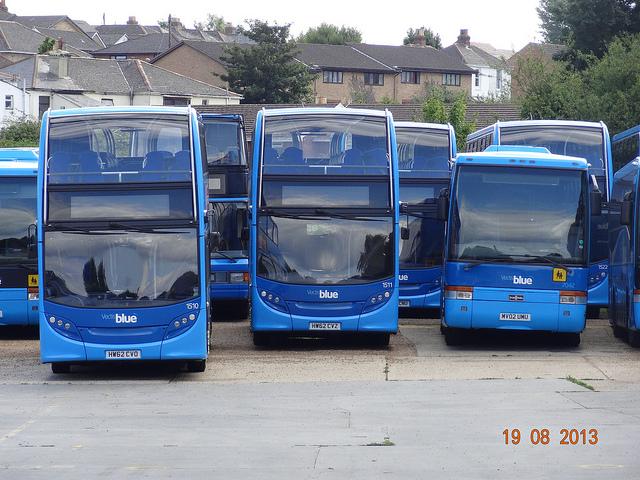What color is the buses?
Keep it brief. Blue. How many buses are there?
Short answer required. 8. Are all of the buses double decker?
Give a very brief answer. No. 